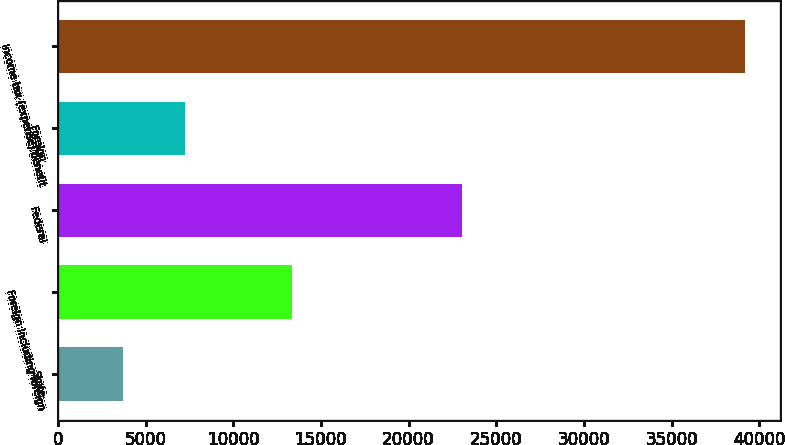<chart> <loc_0><loc_0><loc_500><loc_500><bar_chart><fcel>State<fcel>Foreign including foreign<fcel>Federal<fcel>Foreign<fcel>Income tax (expense) benefit<nl><fcel>3699<fcel>13370<fcel>23070<fcel>7248.8<fcel>39197<nl></chart> 